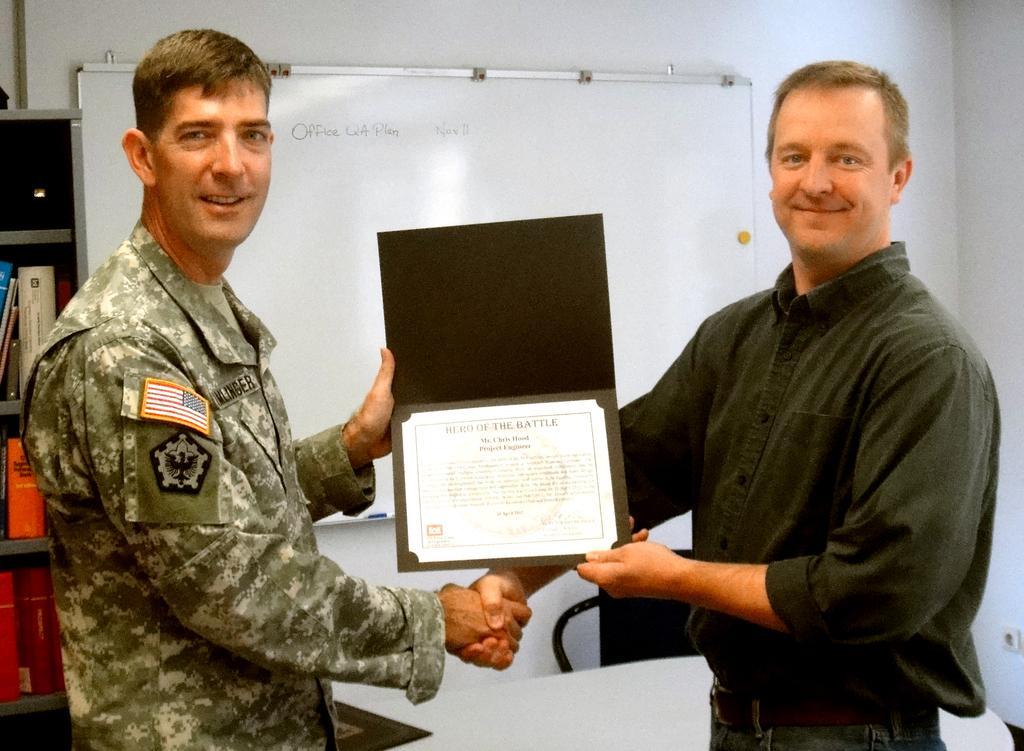Please provide a concise description of this image. On the left side, there is a person in an uniform, smiling, standing, shaking hand with one hand and holding a certificate with other hand. On the right side, there is a person in a shirt, smiling, standing, shaking hand with one hand and holding a certificate with other hand. In the background, there is a white color board which is attached to the white wall and there are files arranged on the shelves. 